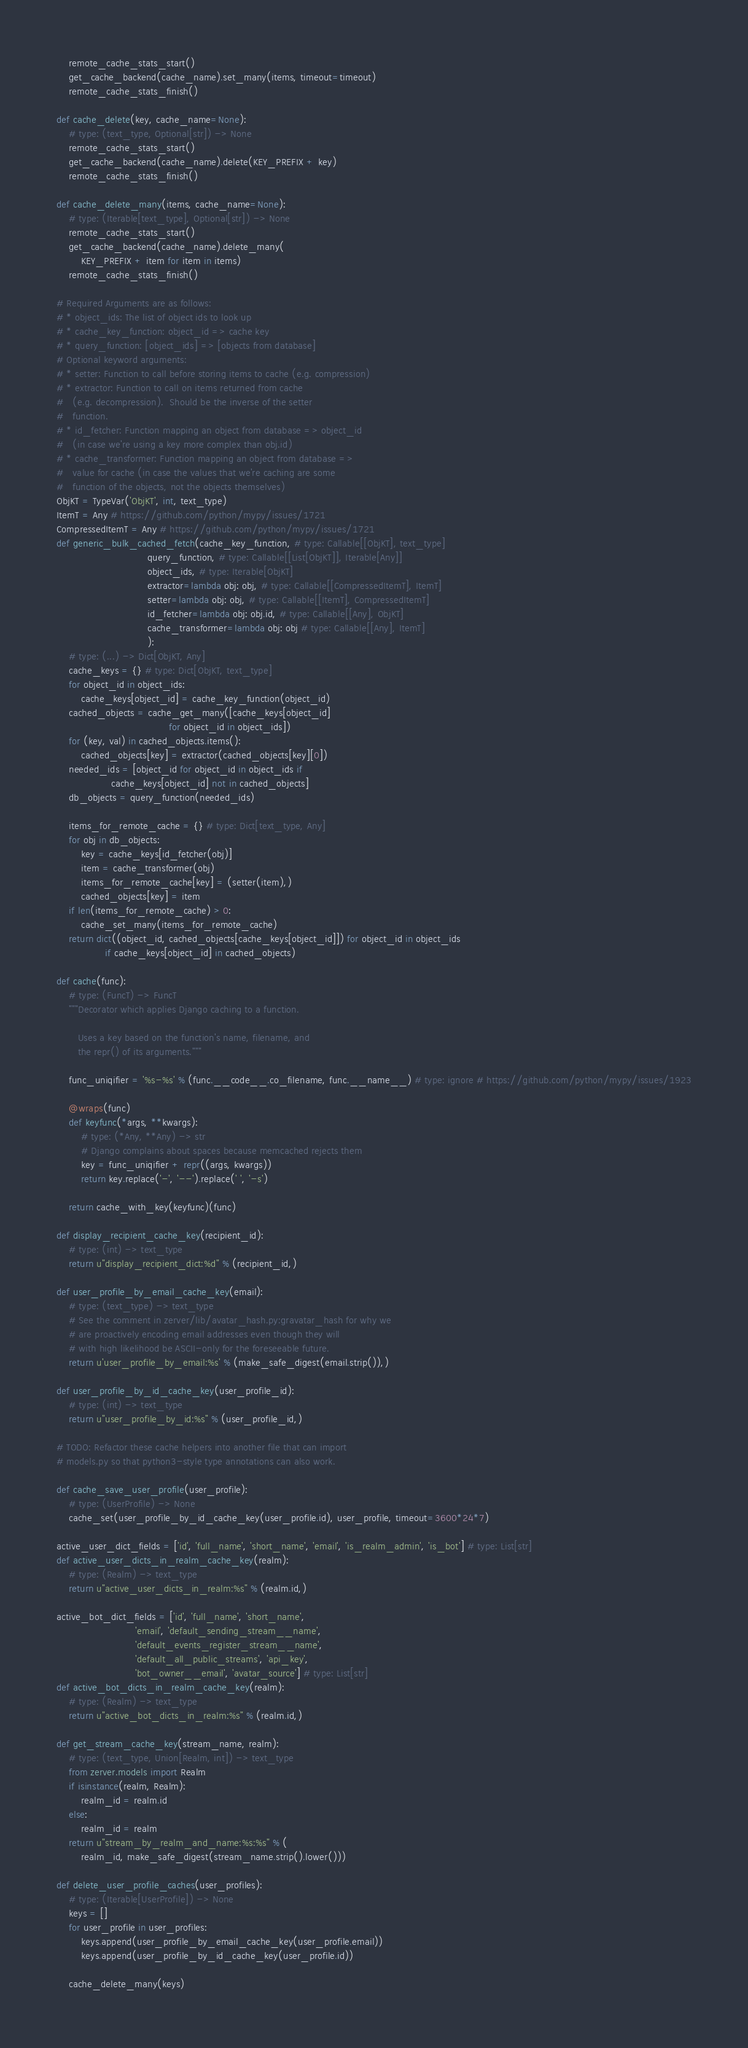<code> <loc_0><loc_0><loc_500><loc_500><_Python_>    remote_cache_stats_start()
    get_cache_backend(cache_name).set_many(items, timeout=timeout)
    remote_cache_stats_finish()

def cache_delete(key, cache_name=None):
    # type: (text_type, Optional[str]) -> None
    remote_cache_stats_start()
    get_cache_backend(cache_name).delete(KEY_PREFIX + key)
    remote_cache_stats_finish()

def cache_delete_many(items, cache_name=None):
    # type: (Iterable[text_type], Optional[str]) -> None
    remote_cache_stats_start()
    get_cache_backend(cache_name).delete_many(
        KEY_PREFIX + item for item in items)
    remote_cache_stats_finish()

# Required Arguments are as follows:
# * object_ids: The list of object ids to look up
# * cache_key_function: object_id => cache key
# * query_function: [object_ids] => [objects from database]
# Optional keyword arguments:
# * setter: Function to call before storing items to cache (e.g. compression)
# * extractor: Function to call on items returned from cache
#   (e.g. decompression).  Should be the inverse of the setter
#   function.
# * id_fetcher: Function mapping an object from database => object_id
#   (in case we're using a key more complex than obj.id)
# * cache_transformer: Function mapping an object from database =>
#   value for cache (in case the values that we're caching are some
#   function of the objects, not the objects themselves)
ObjKT = TypeVar('ObjKT', int, text_type)
ItemT = Any # https://github.com/python/mypy/issues/1721
CompressedItemT = Any # https://github.com/python/mypy/issues/1721
def generic_bulk_cached_fetch(cache_key_function, # type: Callable[[ObjKT], text_type]
                              query_function, # type: Callable[[List[ObjKT]], Iterable[Any]]
                              object_ids, # type: Iterable[ObjKT]
                              extractor=lambda obj: obj, # type: Callable[[CompressedItemT], ItemT]
                              setter=lambda obj: obj, # type: Callable[[ItemT], CompressedItemT]
                              id_fetcher=lambda obj: obj.id, # type: Callable[[Any], ObjKT]
                              cache_transformer=lambda obj: obj # type: Callable[[Any], ItemT]
                              ):
    # type: (...) -> Dict[ObjKT, Any]
    cache_keys = {} # type: Dict[ObjKT, text_type]
    for object_id in object_ids:
        cache_keys[object_id] = cache_key_function(object_id)
    cached_objects = cache_get_many([cache_keys[object_id]
                                     for object_id in object_ids])
    for (key, val) in cached_objects.items():
        cached_objects[key] = extractor(cached_objects[key][0])
    needed_ids = [object_id for object_id in object_ids if
                  cache_keys[object_id] not in cached_objects]
    db_objects = query_function(needed_ids)

    items_for_remote_cache = {} # type: Dict[text_type, Any]
    for obj in db_objects:
        key = cache_keys[id_fetcher(obj)]
        item = cache_transformer(obj)
        items_for_remote_cache[key] = (setter(item),)
        cached_objects[key] = item
    if len(items_for_remote_cache) > 0:
        cache_set_many(items_for_remote_cache)
    return dict((object_id, cached_objects[cache_keys[object_id]]) for object_id in object_ids
                if cache_keys[object_id] in cached_objects)

def cache(func):
    # type: (FuncT) -> FuncT
    """Decorator which applies Django caching to a function.

       Uses a key based on the function's name, filename, and
       the repr() of its arguments."""

    func_uniqifier = '%s-%s' % (func.__code__.co_filename, func.__name__) # type: ignore # https://github.com/python/mypy/issues/1923

    @wraps(func)
    def keyfunc(*args, **kwargs):
        # type: (*Any, **Any) -> str
        # Django complains about spaces because memcached rejects them
        key = func_uniqifier + repr((args, kwargs))
        return key.replace('-', '--').replace(' ', '-s')

    return cache_with_key(keyfunc)(func)

def display_recipient_cache_key(recipient_id):
    # type: (int) -> text_type
    return u"display_recipient_dict:%d" % (recipient_id,)

def user_profile_by_email_cache_key(email):
    # type: (text_type) -> text_type
    # See the comment in zerver/lib/avatar_hash.py:gravatar_hash for why we
    # are proactively encoding email addresses even though they will
    # with high likelihood be ASCII-only for the foreseeable future.
    return u'user_profile_by_email:%s' % (make_safe_digest(email.strip()),)

def user_profile_by_id_cache_key(user_profile_id):
    # type: (int) -> text_type
    return u"user_profile_by_id:%s" % (user_profile_id,)

# TODO: Refactor these cache helpers into another file that can import
# models.py so that python3-style type annotations can also work.

def cache_save_user_profile(user_profile):
    # type: (UserProfile) -> None
    cache_set(user_profile_by_id_cache_key(user_profile.id), user_profile, timeout=3600*24*7)

active_user_dict_fields = ['id', 'full_name', 'short_name', 'email', 'is_realm_admin', 'is_bot'] # type: List[str]
def active_user_dicts_in_realm_cache_key(realm):
    # type: (Realm) -> text_type
    return u"active_user_dicts_in_realm:%s" % (realm.id,)

active_bot_dict_fields = ['id', 'full_name', 'short_name',
                          'email', 'default_sending_stream__name',
                          'default_events_register_stream__name',
                          'default_all_public_streams', 'api_key',
                          'bot_owner__email', 'avatar_source'] # type: List[str]
def active_bot_dicts_in_realm_cache_key(realm):
    # type: (Realm) -> text_type
    return u"active_bot_dicts_in_realm:%s" % (realm.id,)

def get_stream_cache_key(stream_name, realm):
    # type: (text_type, Union[Realm, int]) -> text_type
    from zerver.models import Realm
    if isinstance(realm, Realm):
        realm_id = realm.id
    else:
        realm_id = realm
    return u"stream_by_realm_and_name:%s:%s" % (
        realm_id, make_safe_digest(stream_name.strip().lower()))

def delete_user_profile_caches(user_profiles):
    # type: (Iterable[UserProfile]) -> None
    keys = []
    for user_profile in user_profiles:
        keys.append(user_profile_by_email_cache_key(user_profile.email))
        keys.append(user_profile_by_id_cache_key(user_profile.id))

    cache_delete_many(keys)
</code> 